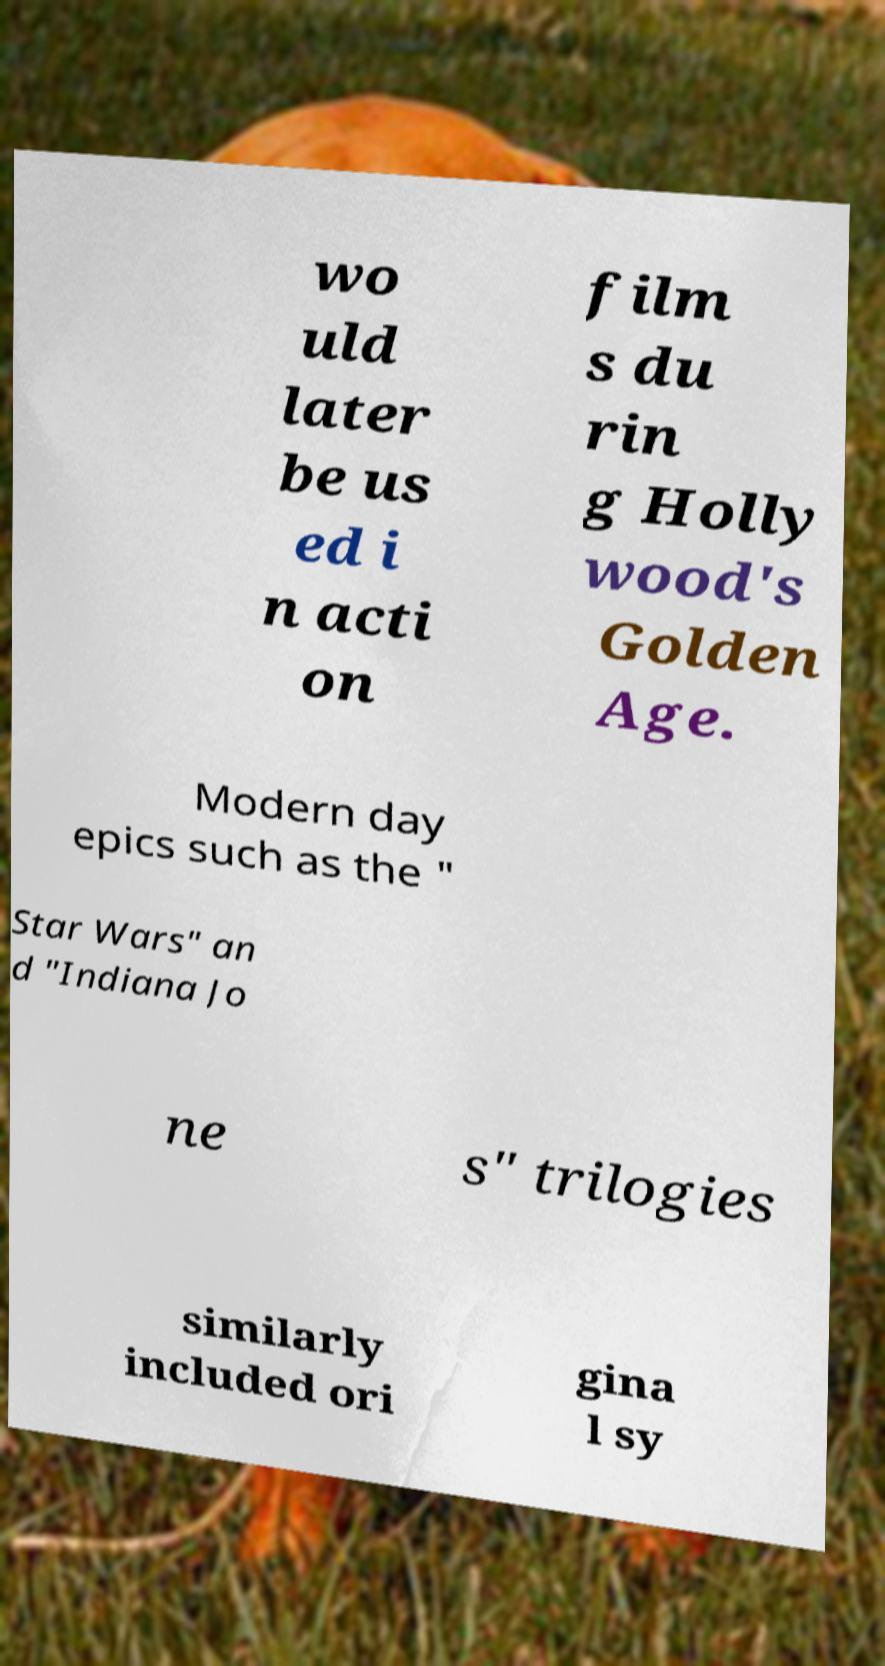I need the written content from this picture converted into text. Can you do that? wo uld later be us ed i n acti on film s du rin g Holly wood's Golden Age. Modern day epics such as the " Star Wars" an d "Indiana Jo ne s" trilogies similarly included ori gina l sy 